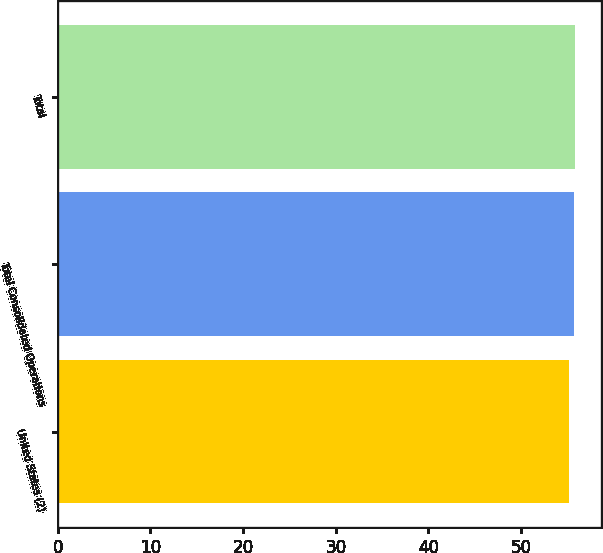Convert chart to OTSL. <chart><loc_0><loc_0><loc_500><loc_500><bar_chart><fcel>United States (2)<fcel>Total Consolidated Operations<fcel>Total<nl><fcel>55.19<fcel>55.76<fcel>55.87<nl></chart> 